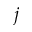<formula> <loc_0><loc_0><loc_500><loc_500>j</formula> 